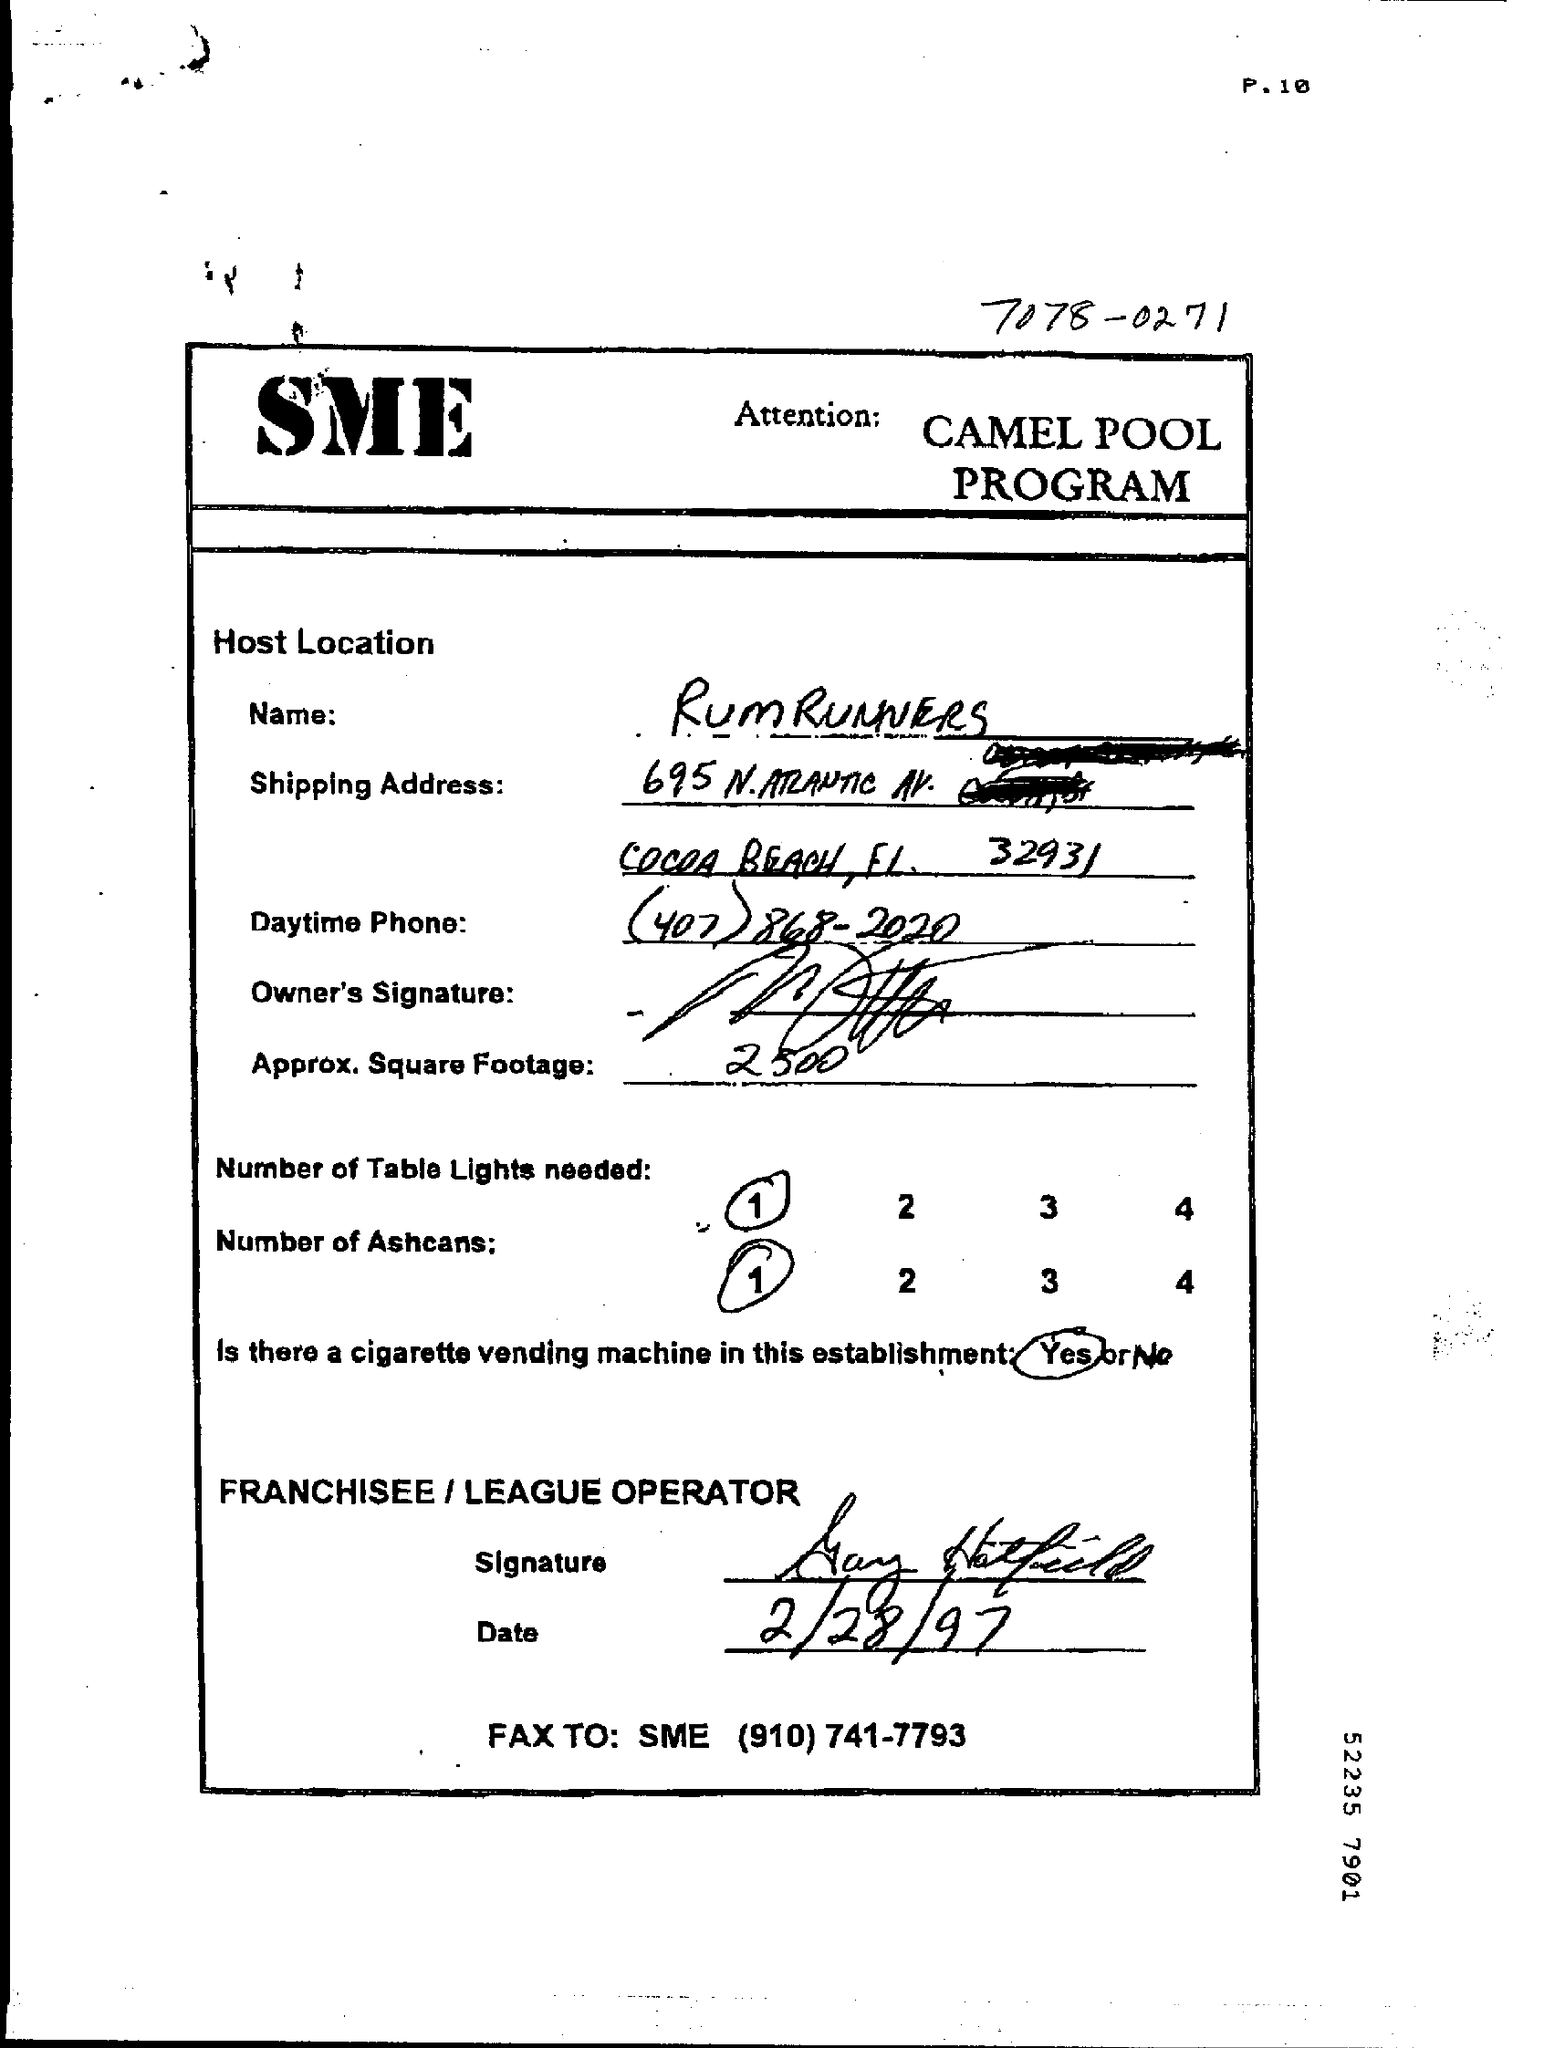Which name is mentioned?
Keep it short and to the point. RUM RUNNERS. Date of the document?
Offer a terse response. 2/28/97. 